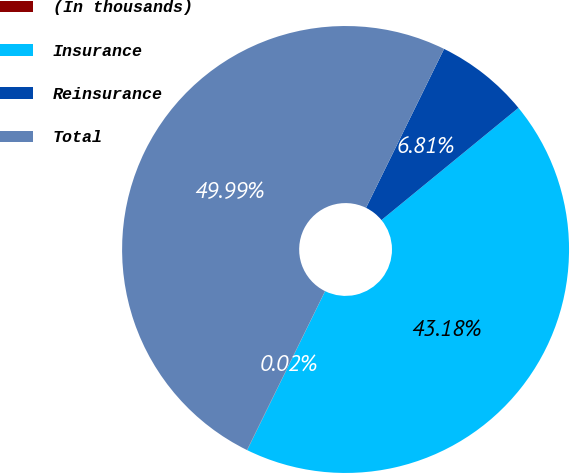Convert chart. <chart><loc_0><loc_0><loc_500><loc_500><pie_chart><fcel>(In thousands)<fcel>Insurance<fcel>Reinsurance<fcel>Total<nl><fcel>0.02%<fcel>43.18%<fcel>6.81%<fcel>49.99%<nl></chart> 